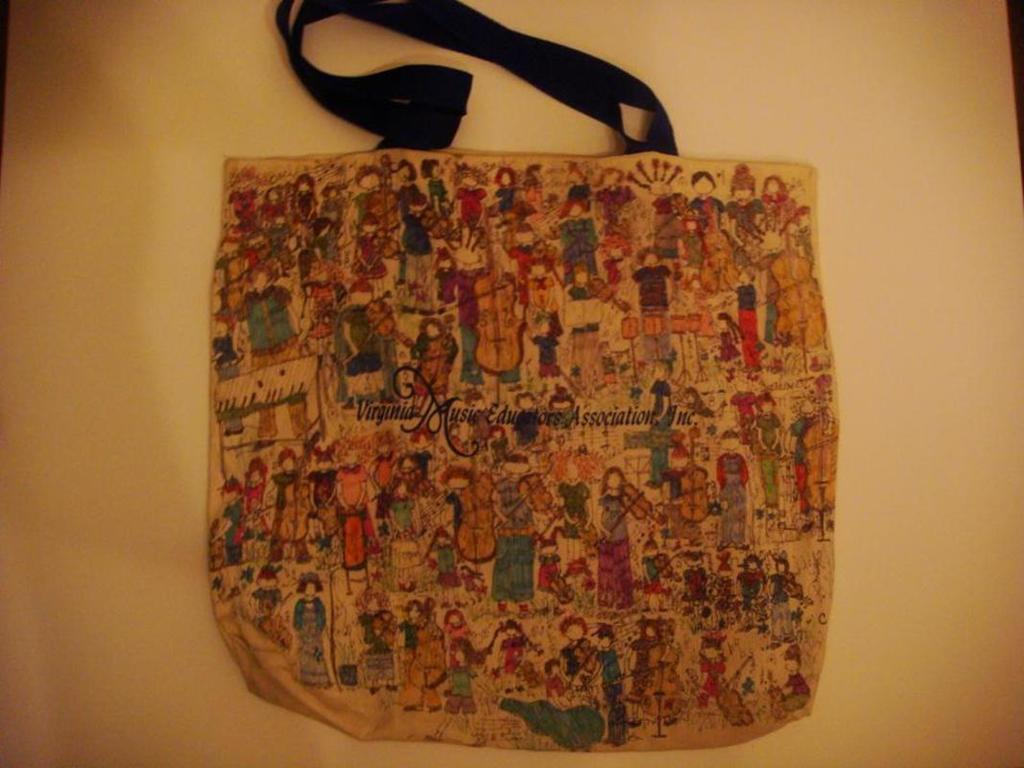What object is present in the image? There is a bag in the picture. What is depicted on the bag? The bag has art and paintings on it. What is the color of the background in the image? The background of the image is cream white in color. How many sugar cubes are visible in the image? There are no sugar cubes present in the image. Are there any trains visible in the image? There are no trains present in the image. 